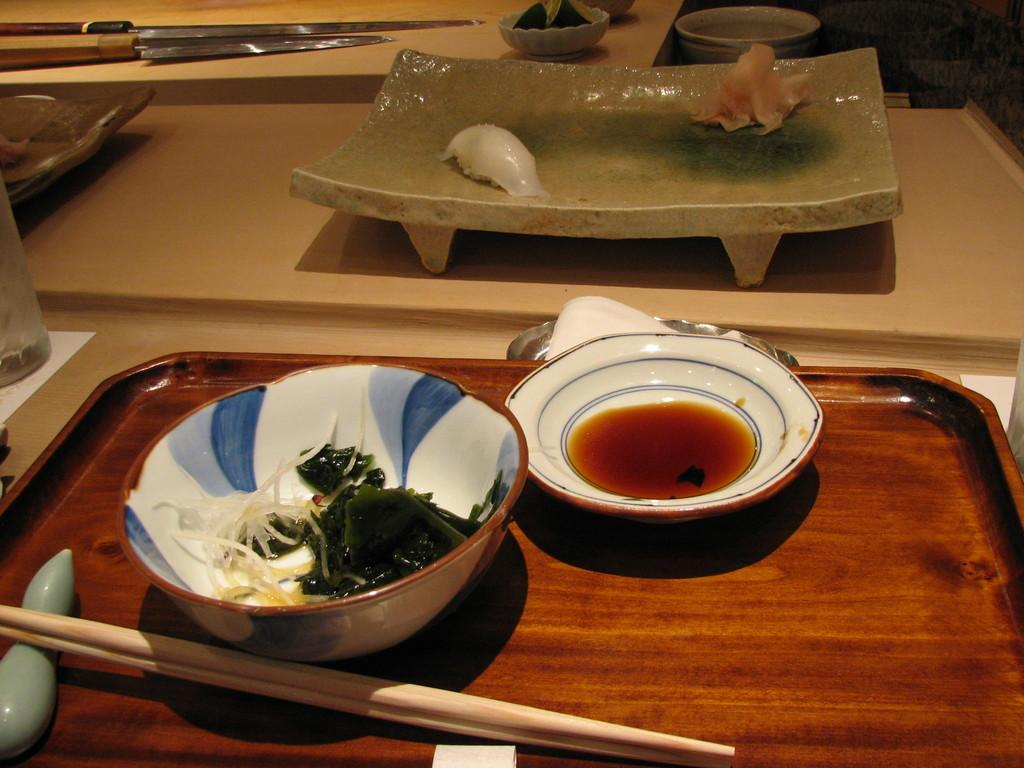What piece of furniture is present in the image? There is a table in the image. What is on the table? There is a bowl and cups on the table. How are the cups arranged on the table? The cups are on a tray. Are there any other tables in the image? Yes, there is another table in the image. What is on the second table? There is a stand on the second table. What is placed on the stand? There are items placed on the stand. How many strings are attached to the chair in the image? There is no chair present in the image, and therefore no strings can be attached to it. Can you describe the owl sitting on the stand in the image? There is no owl present in the image; only items placed on the stand are visible. 